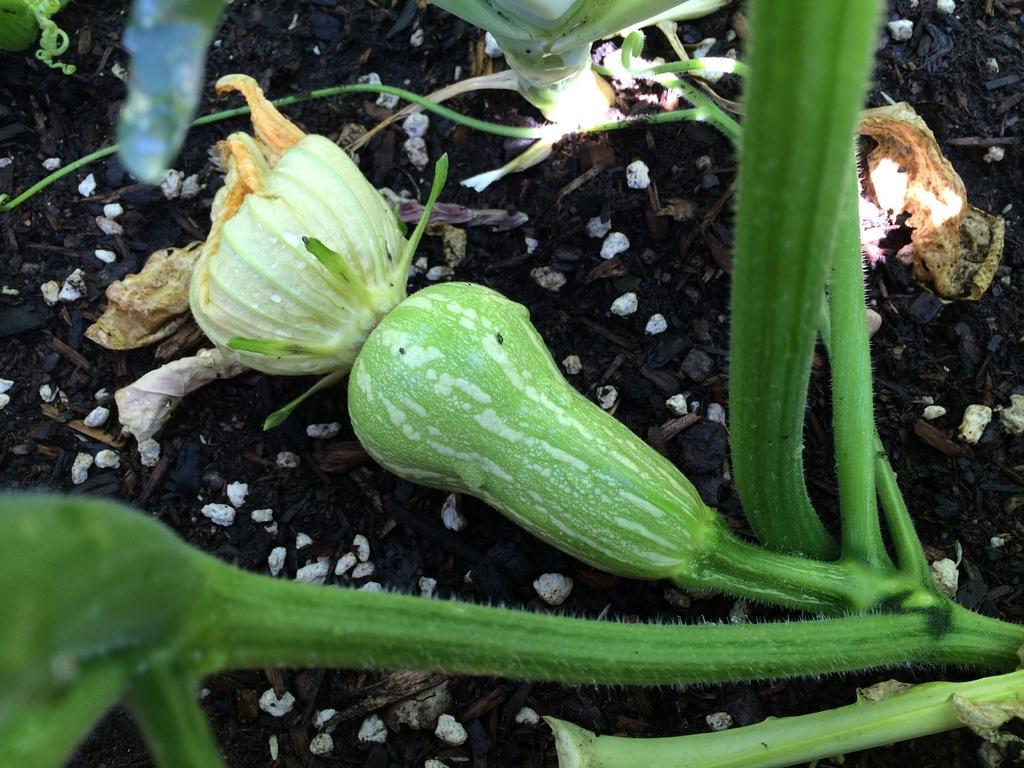In one or two sentences, can you explain what this image depicts? In this image there is a vegetable on the ground. 